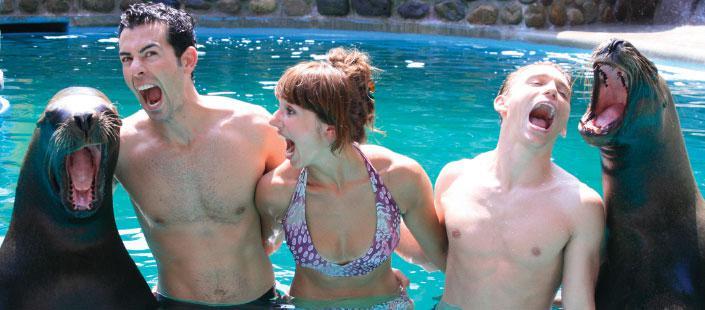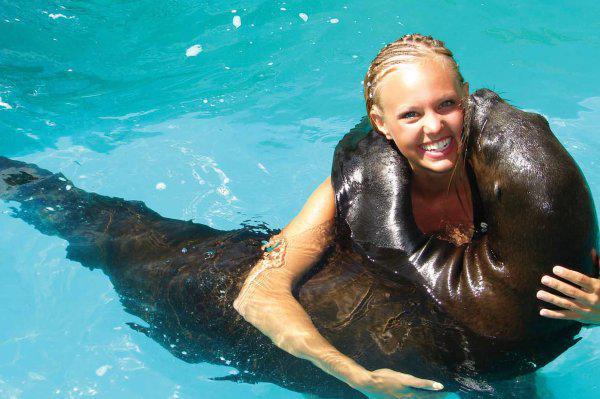The first image is the image on the left, the second image is the image on the right. Considering the images on both sides, is "The right image includes twice the number of people and seals in the foreground as the left image." valid? Answer yes or no. No. The first image is the image on the left, the second image is the image on the right. Evaluate the accuracy of this statement regarding the images: "Two people are in the water with two sea animals in one of the pictures.". Is it true? Answer yes or no. No. 